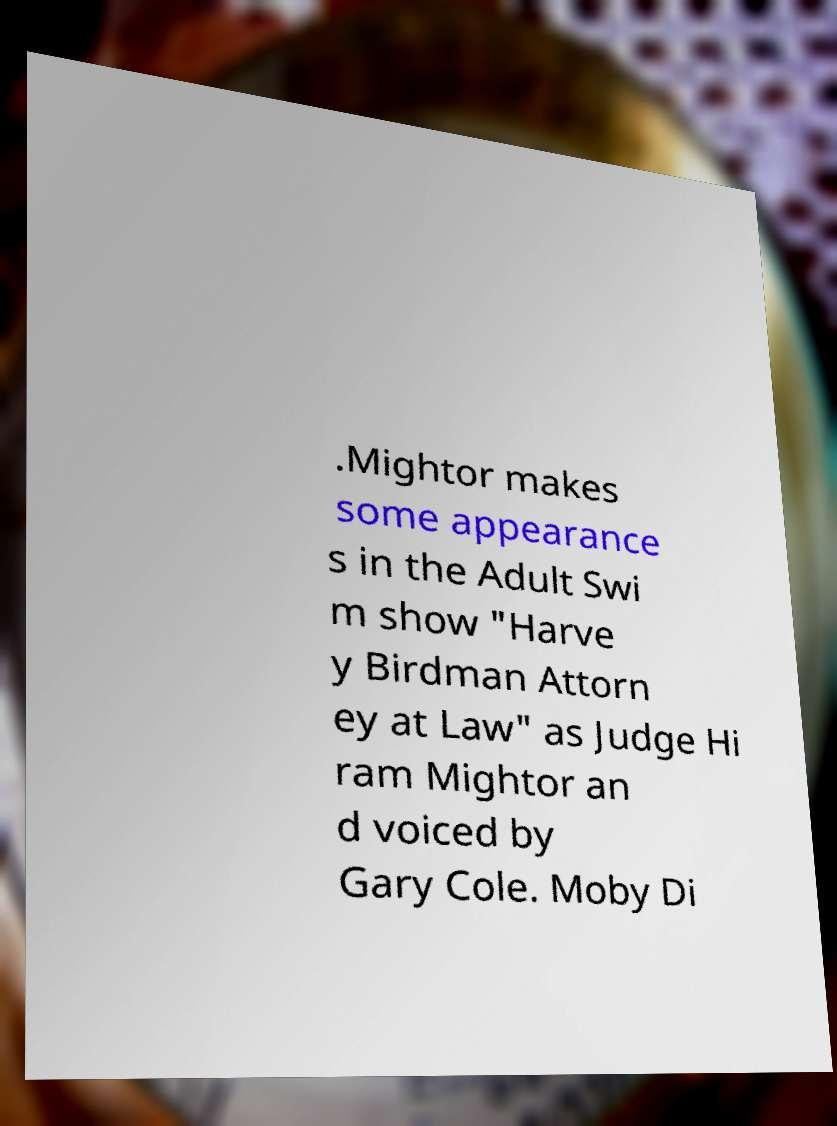Please read and relay the text visible in this image. What does it say? .Mightor makes some appearance s in the Adult Swi m show "Harve y Birdman Attorn ey at Law" as Judge Hi ram Mightor an d voiced by Gary Cole. Moby Di 